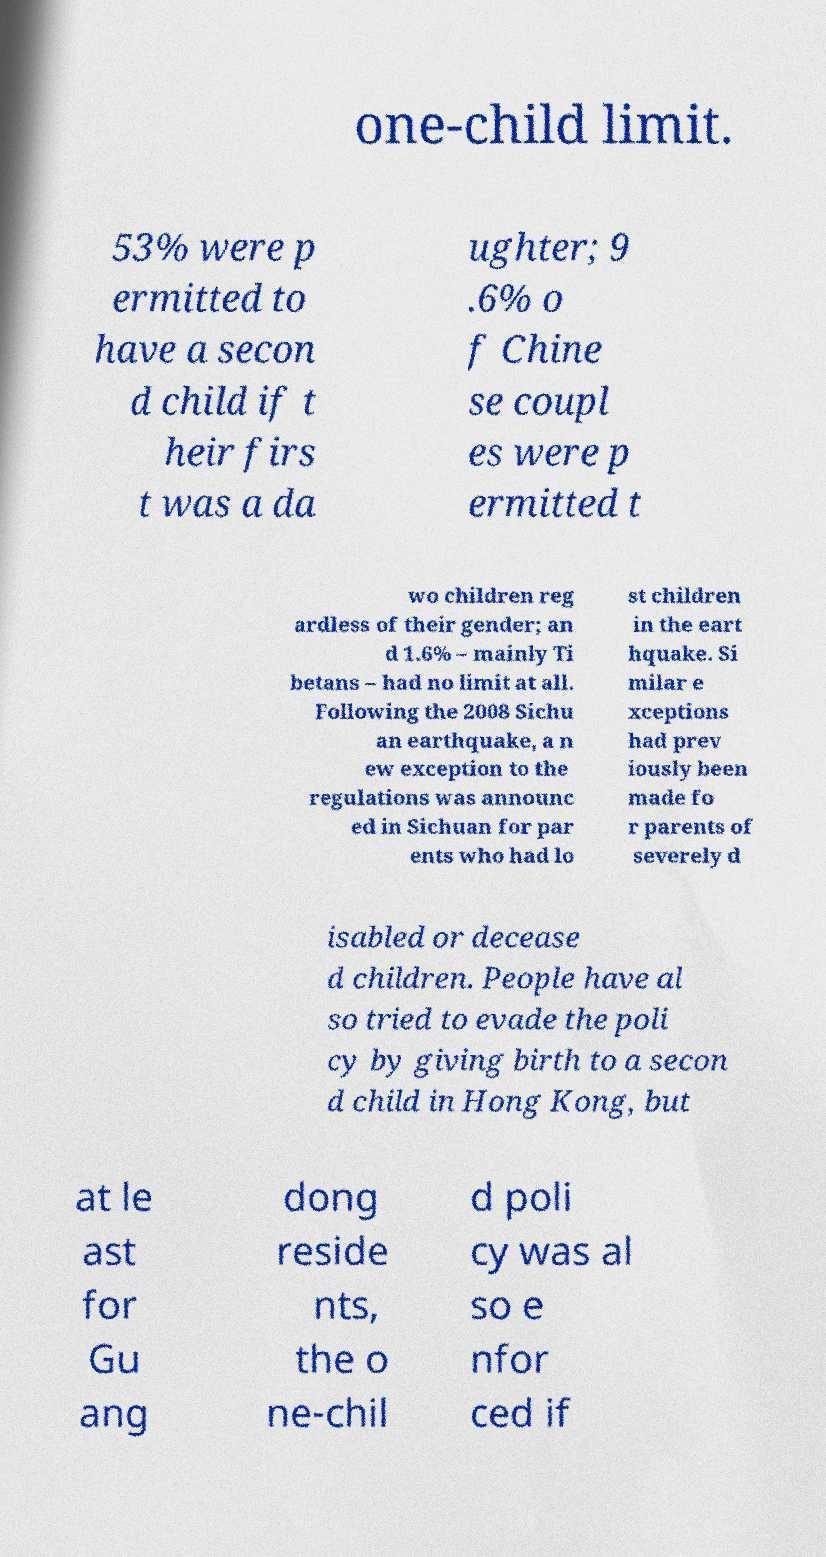Could you assist in decoding the text presented in this image and type it out clearly? one-child limit. 53% were p ermitted to have a secon d child if t heir firs t was a da ughter; 9 .6% o f Chine se coupl es were p ermitted t wo children reg ardless of their gender; an d 1.6% – mainly Ti betans – had no limit at all. Following the 2008 Sichu an earthquake, a n ew exception to the regulations was announc ed in Sichuan for par ents who had lo st children in the eart hquake. Si milar e xceptions had prev iously been made fo r parents of severely d isabled or decease d children. People have al so tried to evade the poli cy by giving birth to a secon d child in Hong Kong, but at le ast for Gu ang dong reside nts, the o ne-chil d poli cy was al so e nfor ced if 